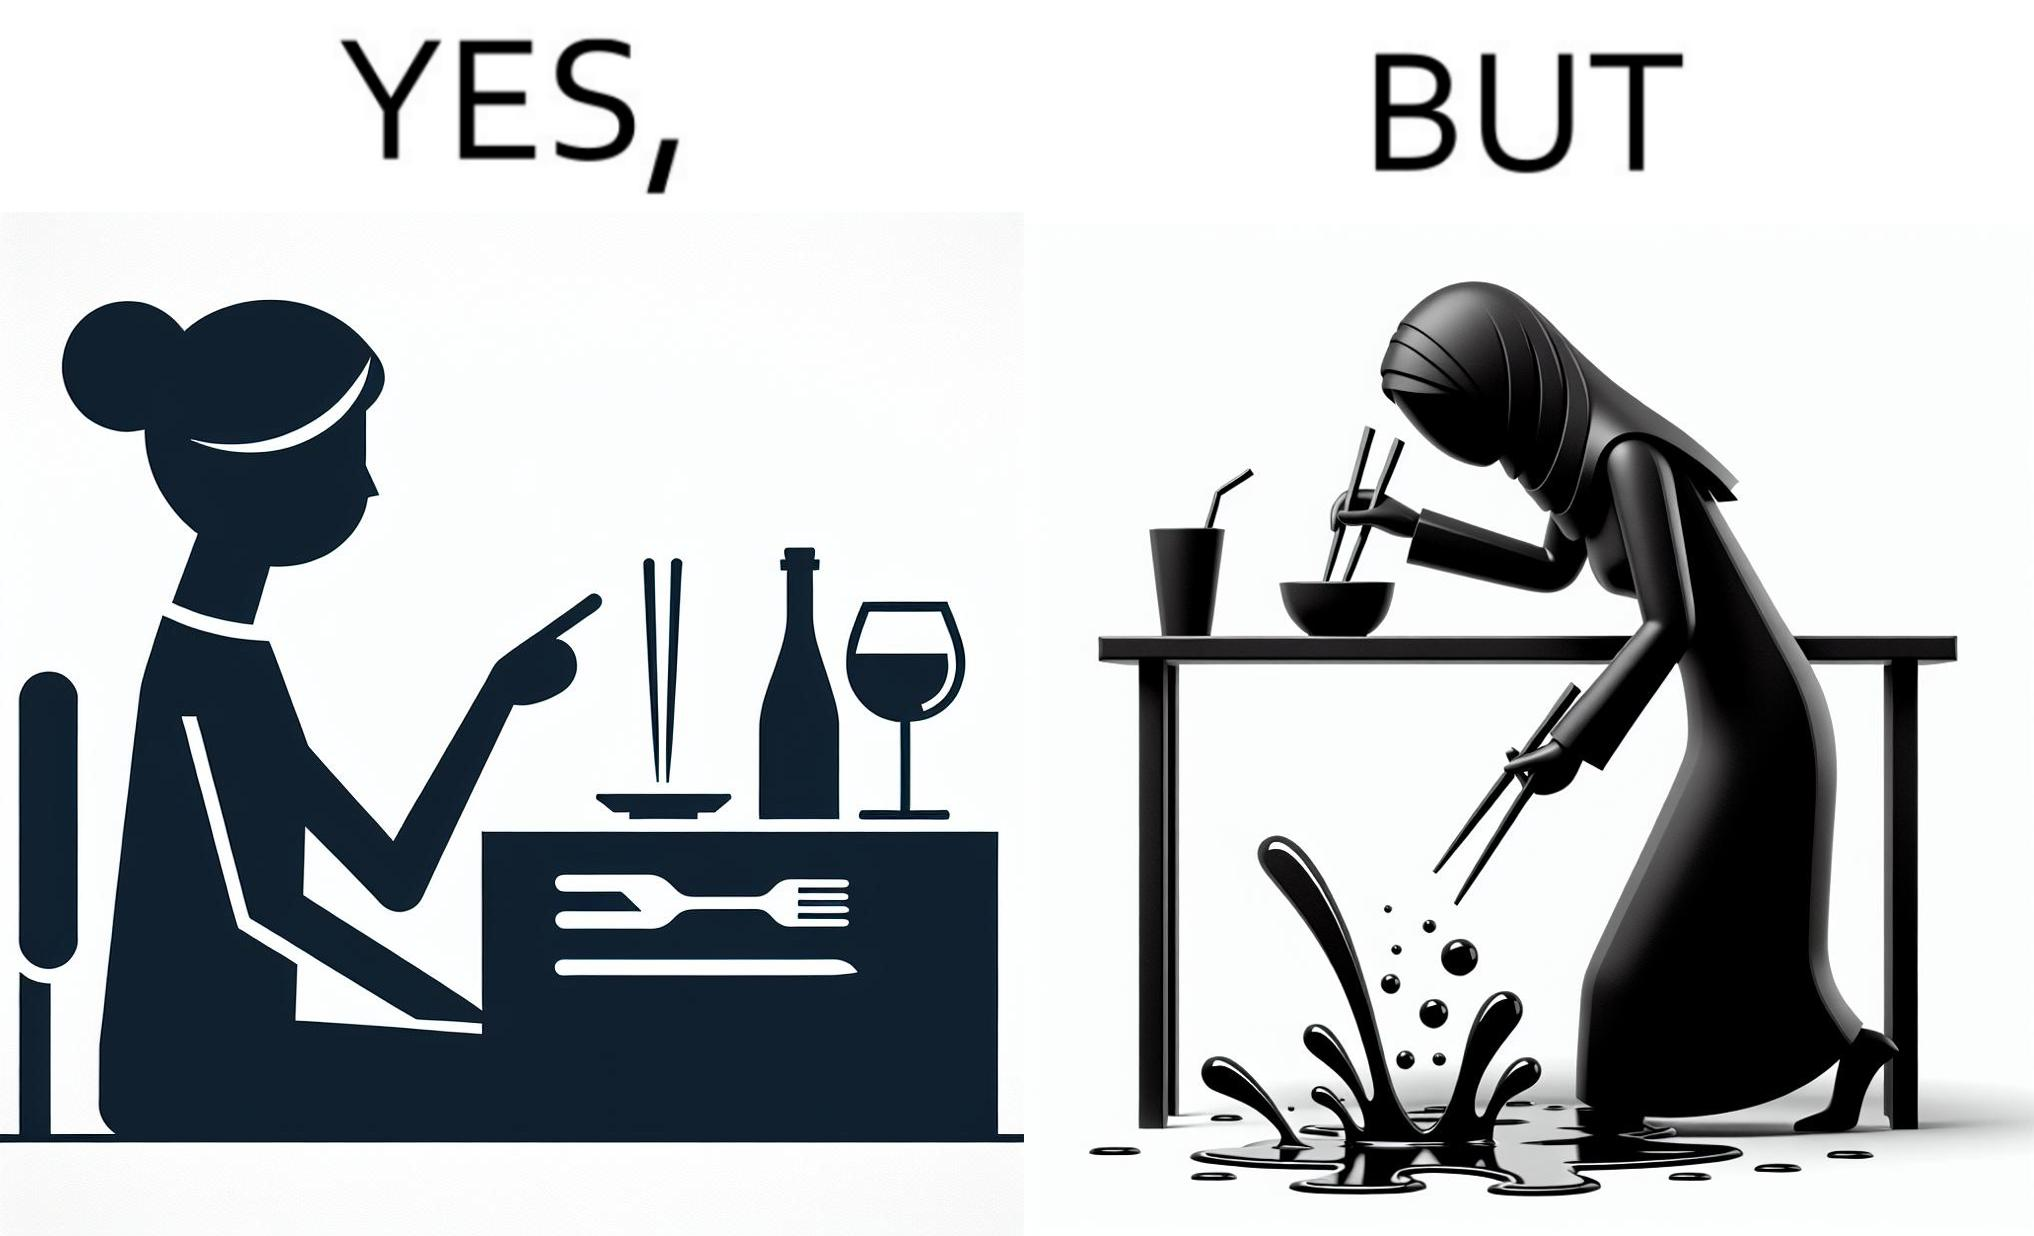What does this image depict? The image is satirical because even thought the woman is not able to eat food with chopstick properly, she chooses it over fork and knife to look sophisticaed. 